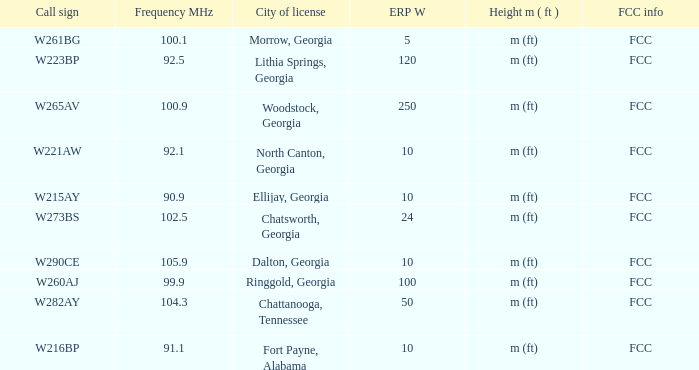What is the lowest ERP W of  w223bp? 120.0. 